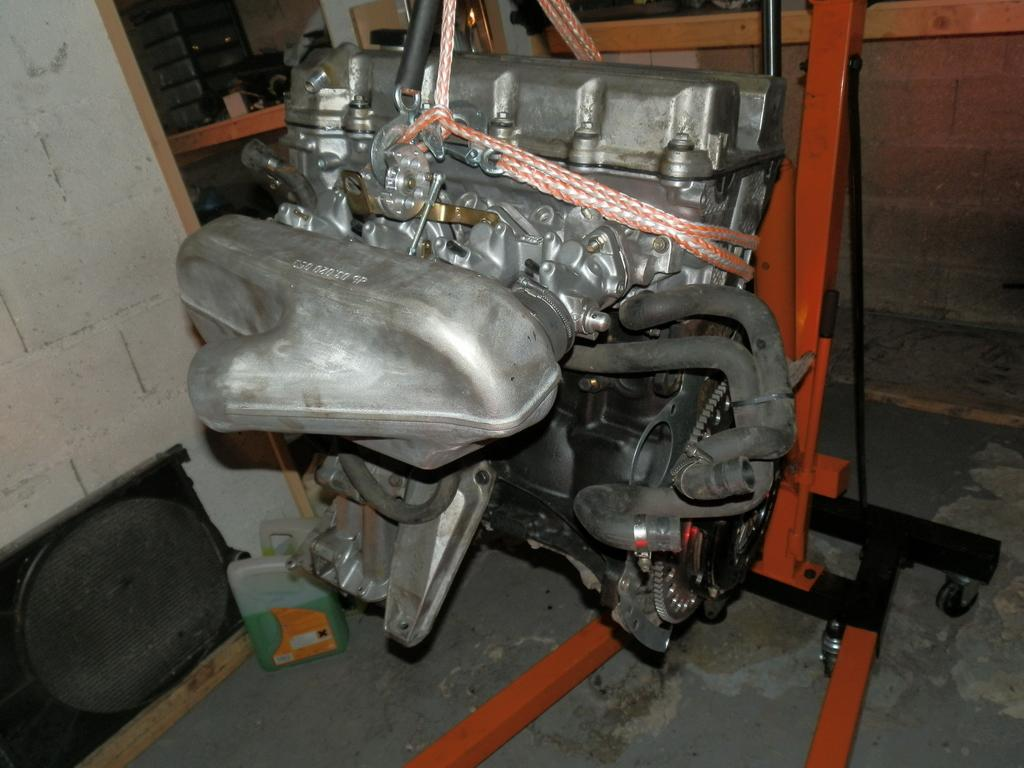What is the main object in the center of the image? There is an engine, a can, and a stand in the center of the image. Can you describe the objects in the center of the image? The engine is likely a mechanical or electrical component, the can could be a container for various purposes, and the stand is a support structure. What can be seen in the background of the image? There is a wall, a table, a speaker, and other objects in the background of the image. What might the speaker be used for in the image? The speaker could be used for amplifying sound or playing music. What type of rhythm can be heard coming from the mouth of the engine in the image? There is no mouth present on the engine in the image, and therefore no rhythm can be heard. 